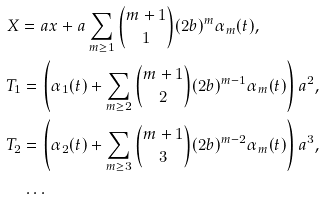<formula> <loc_0><loc_0><loc_500><loc_500>& X = a x + a \sum _ { m \geq 1 } \binom { m + 1 } { 1 } ( 2 b ) ^ { m } \alpha _ { m } ( t ) , \\ & T _ { 1 } = \left ( \alpha _ { 1 } ( t ) + \sum _ { m \geq 2 } \binom { m + 1 } { 2 } ( 2 b ) ^ { m - 1 } \alpha _ { m } ( t ) \right ) a ^ { 2 } , \\ & T _ { 2 } = \left ( \alpha _ { 2 } ( t ) + \sum _ { m \geq 3 } \binom { m + 1 } { 3 } ( 2 b ) ^ { m - 2 } \alpha _ { m } ( t ) \right ) a ^ { 3 } , \\ & \quad \dots</formula> 